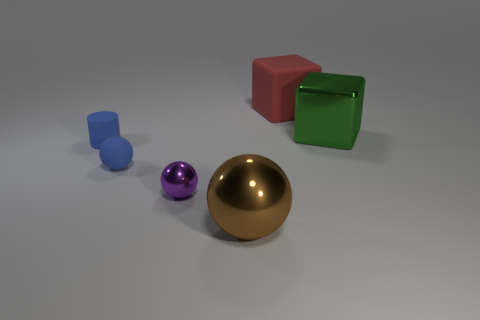There is a small thing that is the same color as the rubber ball; what is it made of?
Ensure brevity in your answer.  Rubber. What number of tiny things are purple objects or metallic cubes?
Provide a short and direct response. 1. What color is the tiny cylinder?
Make the answer very short. Blue. There is a big green block that is in front of the matte cube; is there a green thing that is behind it?
Ensure brevity in your answer.  No. Are there fewer green metallic objects behind the red rubber block than matte cylinders?
Offer a terse response. Yes. Is the large thing that is to the left of the large rubber thing made of the same material as the blue sphere?
Ensure brevity in your answer.  No. There is a small sphere that is the same material as the large green cube; what color is it?
Offer a terse response. Purple. Are there fewer large red blocks that are in front of the metal cube than large brown metal things in front of the large metallic ball?
Provide a short and direct response. No. There is a shiny sphere that is on the left side of the big brown thing; does it have the same color as the metal object that is to the right of the brown metal thing?
Your answer should be very brief. No. Are there any cyan cylinders that have the same material as the large green block?
Give a very brief answer. No. 